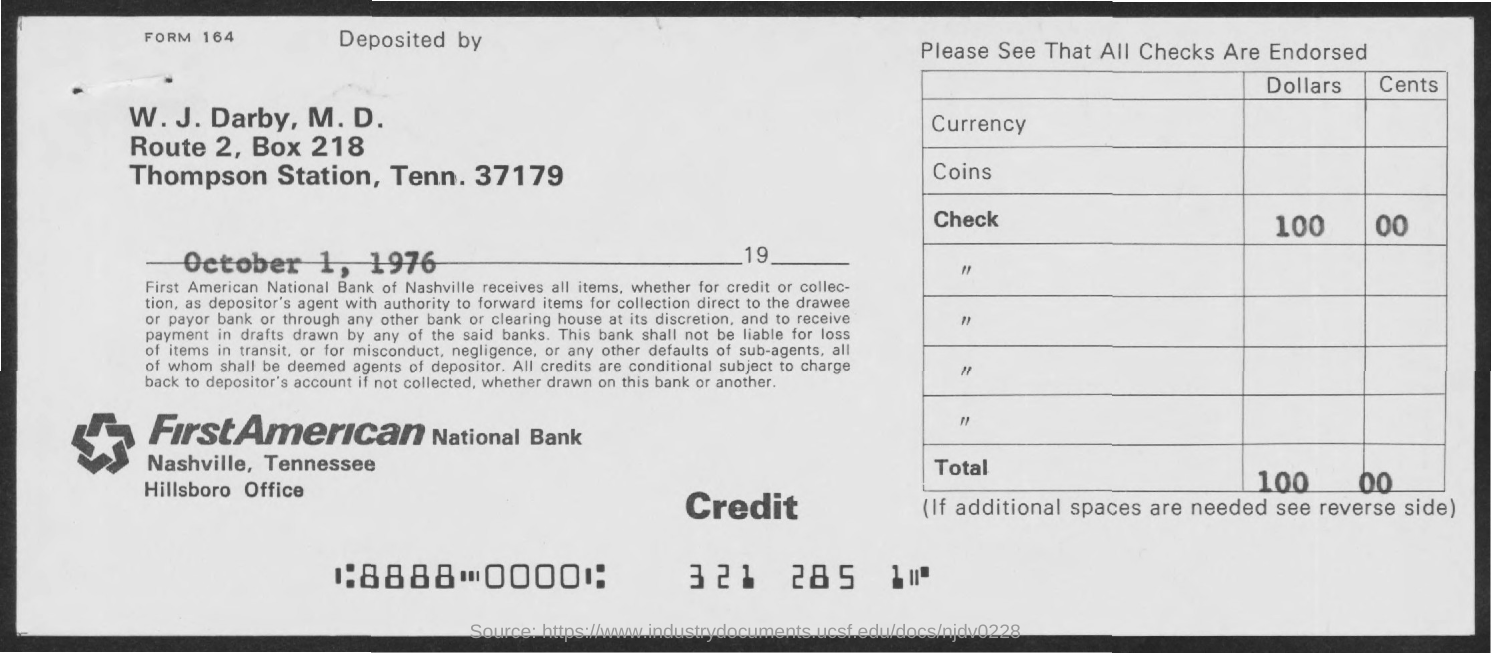What is the BOX Number ?
Ensure brevity in your answer.  218. When is the memorandum dated on ?
Offer a terse response. October 1, 1976. 